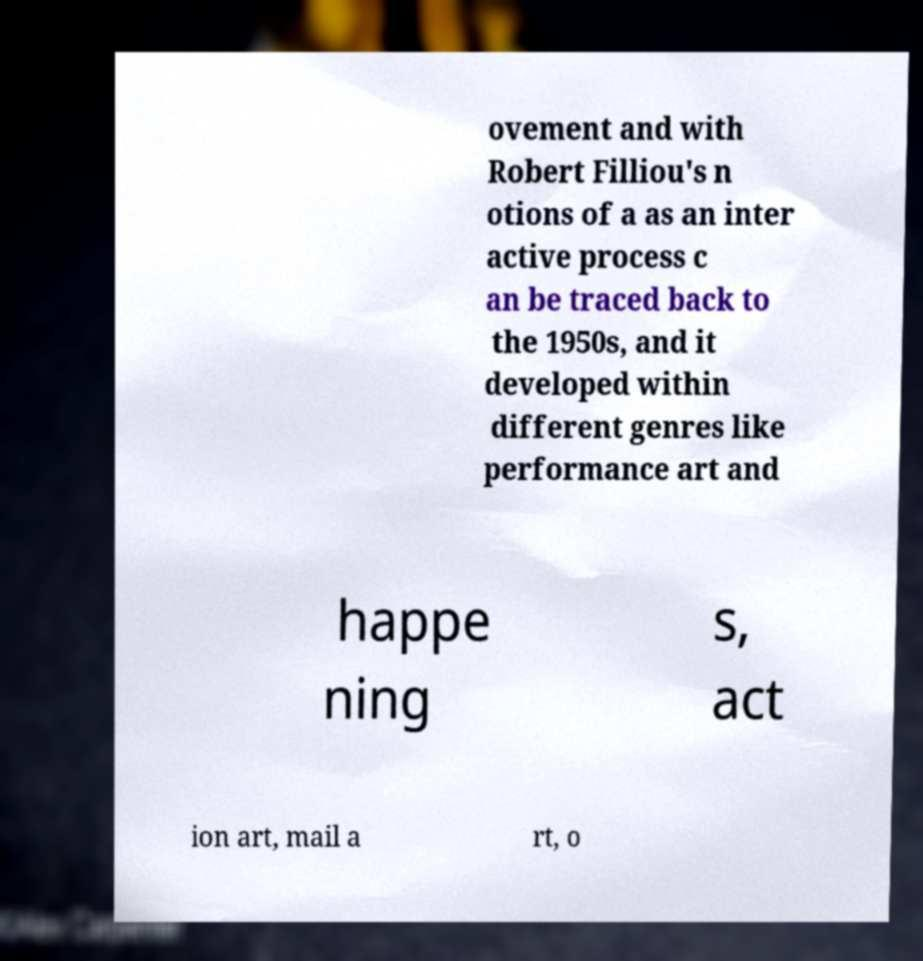I need the written content from this picture converted into text. Can you do that? ovement and with Robert Filliou's n otions of a as an inter active process c an be traced back to the 1950s, and it developed within different genres like performance art and happe ning s, act ion art, mail a rt, o 